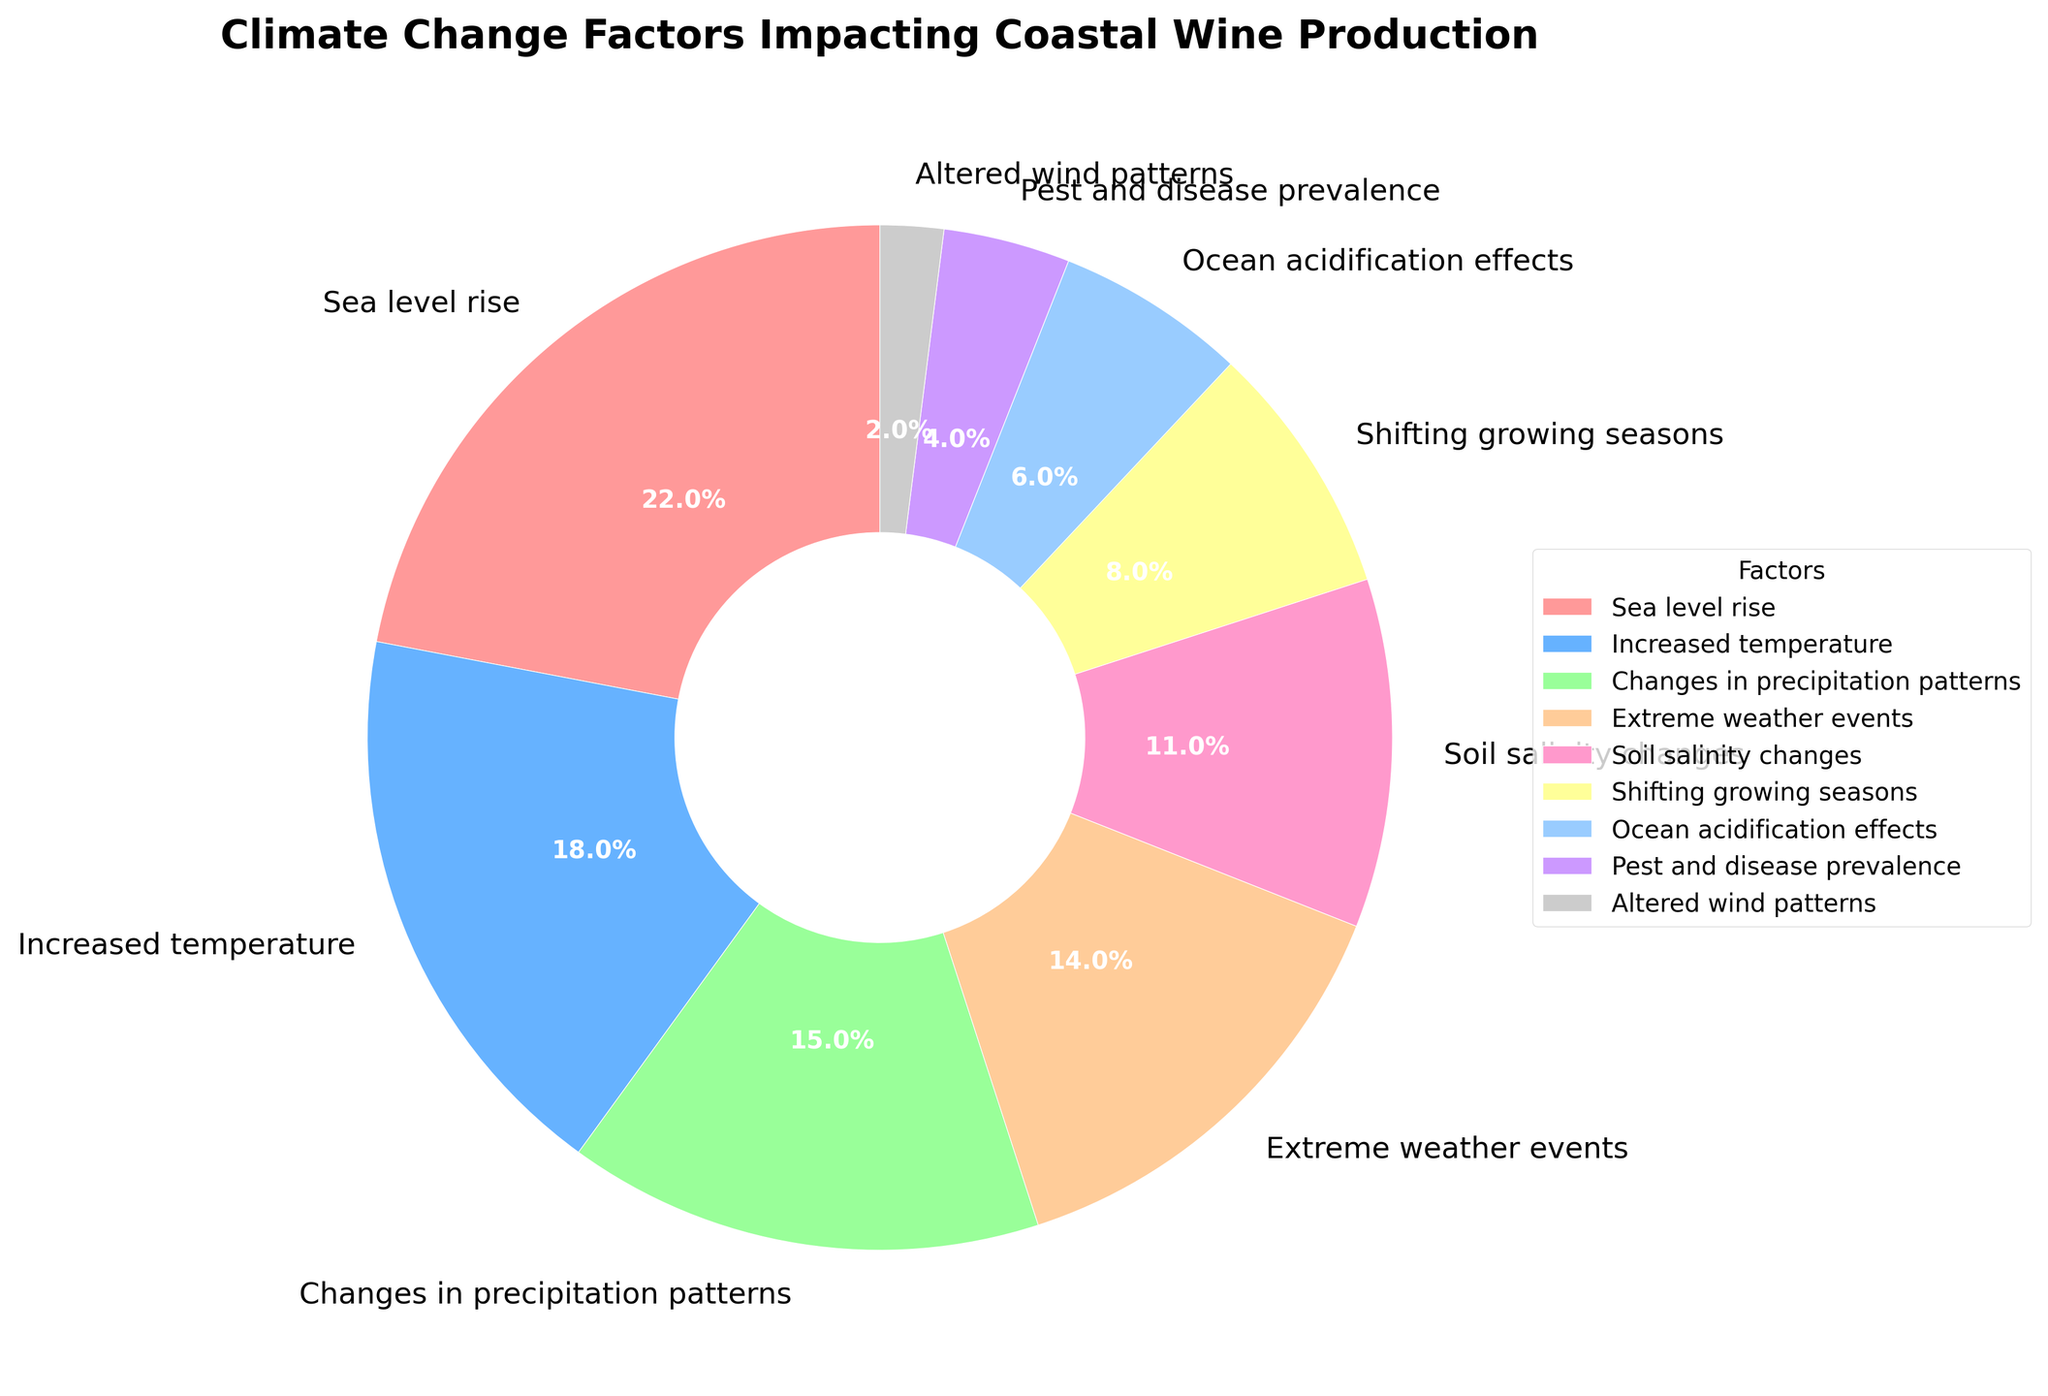What percentage of the climate change-related factors is attributed to sea level rise? The percentage of the climate change-related factors attributed to the sea level rise is labeled directly on the pie chart.
Answer: 22% Which factor has the lowest impact on wine production according to the chart? By inspecting the pie chart, the smallest slice corresponds to "Altered wind patterns," which has the lowest percentage.
Answer: Altered wind patterns What is the combined percentage of factors related to increased temperature and changes in precipitation patterns? According to the pie chart, increased temperature contributes 18% and changes in precipitation patterns contribute 15%. Adding these together, 18% + 15% = 33%.
Answer: 33% Which factor has a greater impact: extreme weather events or soil salinity changes? The pie chart shows that extreme weather events have a 14% impact, while soil salinity changes have an 11% impact. 14% is greater than 11%.
Answer: Extreme weather events How does the impact of shifting growing seasons compare to ocean acidification effects? The pie chart indicates that shifting growing seasons contribute 8%, while ocean acidification effects contribute 6%. Thus, shifting growing seasons have a greater impact.
Answer: Shifting growing seasons What is the total percentage attributed to factors with less than 10% impact each? The factors with less than 10% impact are shifting growing seasons (8%), ocean acidification effects (6%), pest and disease prevalence (4%), and altered wind patterns (2%). Summing these percentages, 8% + 6% + 4% + 2% = 20%.
Answer: 20% Which factor has the closest impact to changes in precipitation patterns? According to the pie chart, soil salinity changes have an 11% impact, and changes in precipitation patterns have a 15% impact. The percentage of soil salinity changes is the closest to changes in precipitation patterns.
Answer: Soil salinity changes What is the difference in impact between increased temperature and pest and disease prevalence? The pie chart shows that the increased temperature has an 18% impact, and pest and disease prevalence has a 4% impact. To find the difference, subtract 4% from 18%, which gives 14%.
Answer: 14% Which color represents the "Sea level rise" factor in the chart? The "Sea level rise" factor's color is identified by locating the corresponding label in the pie chart and finding the adjacent color. It is represented by a red slice.
Answer: Red 